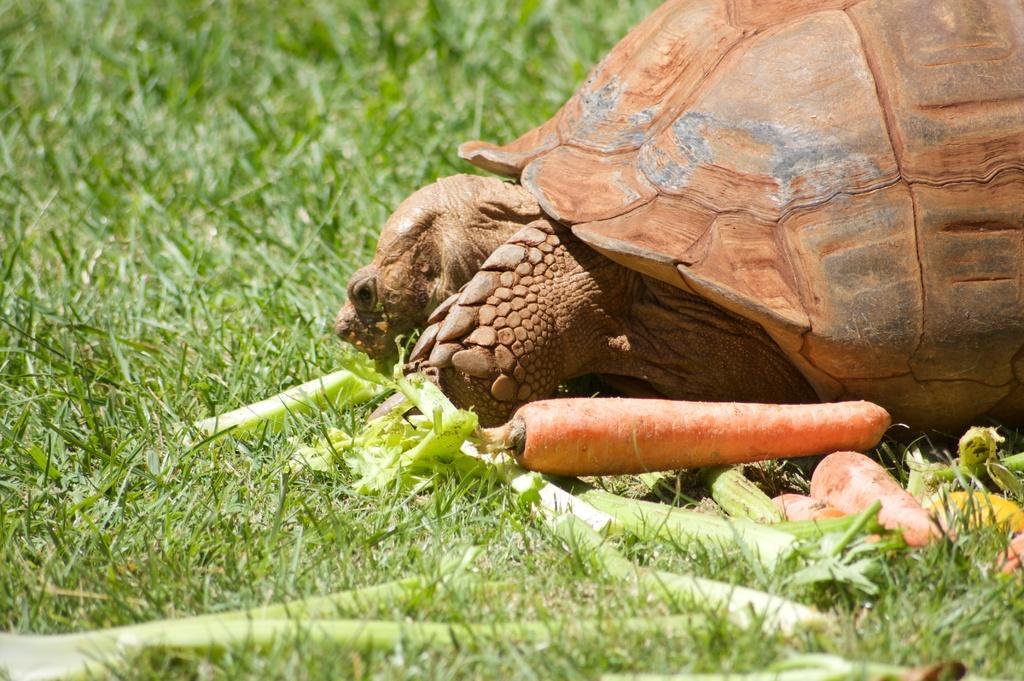In one or two sentences, can you explain what this image depicts? In this image there is a tortoise, vegetables and grass. Land is covered with grass. Near the tortoise there are vegetables. 